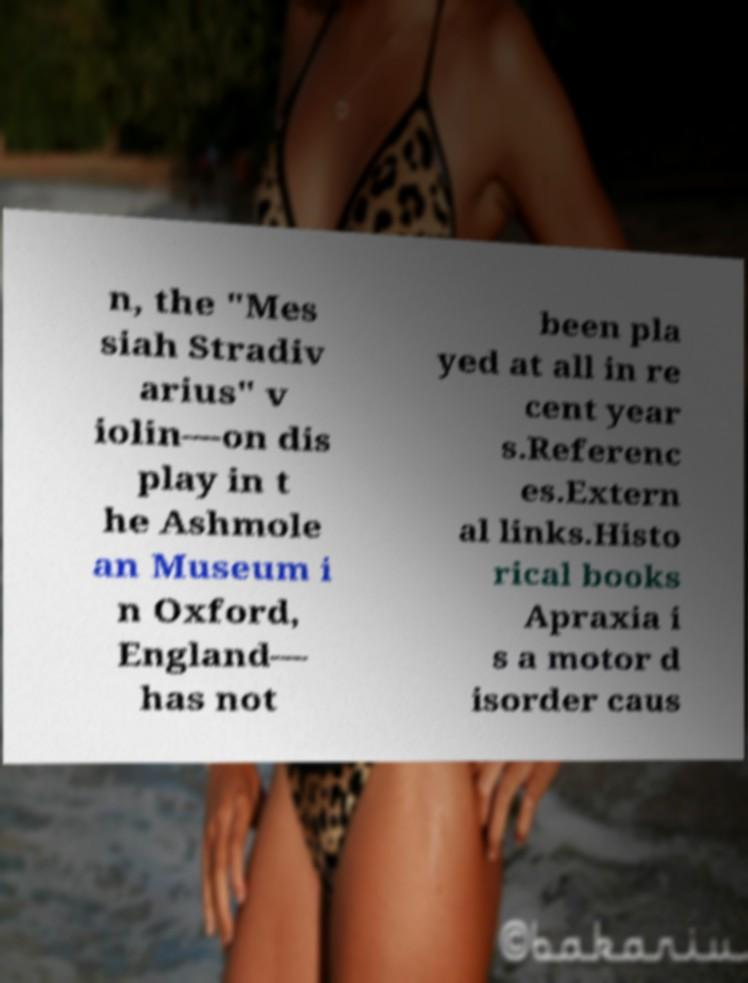Please read and relay the text visible in this image. What does it say? n, the "Mes siah Stradiv arius" v iolin—on dis play in t he Ashmole an Museum i n Oxford, England— has not been pla yed at all in re cent year s.Referenc es.Extern al links.Histo rical books Apraxia i s a motor d isorder caus 